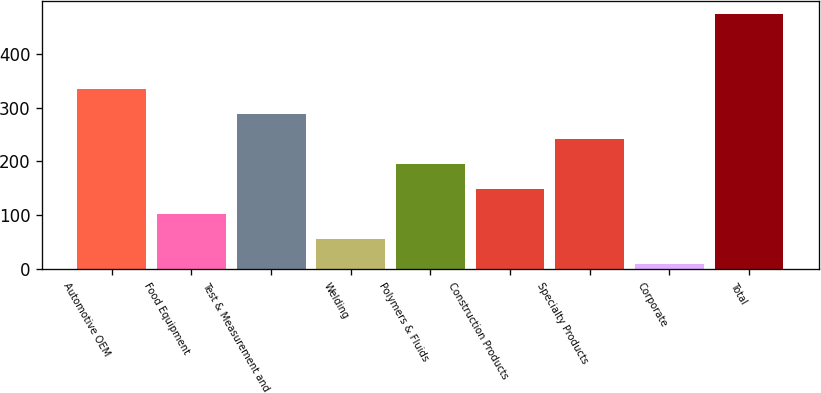Convert chart. <chart><loc_0><loc_0><loc_500><loc_500><bar_chart><fcel>Automotive OEM<fcel>Food Equipment<fcel>Test & Measurement and<fcel>Welding<fcel>Polymers & Fluids<fcel>Construction Products<fcel>Specialty Products<fcel>Corporate<fcel>Total<nl><fcel>335.5<fcel>103<fcel>289<fcel>56.5<fcel>196<fcel>149.5<fcel>242.5<fcel>10<fcel>475<nl></chart> 